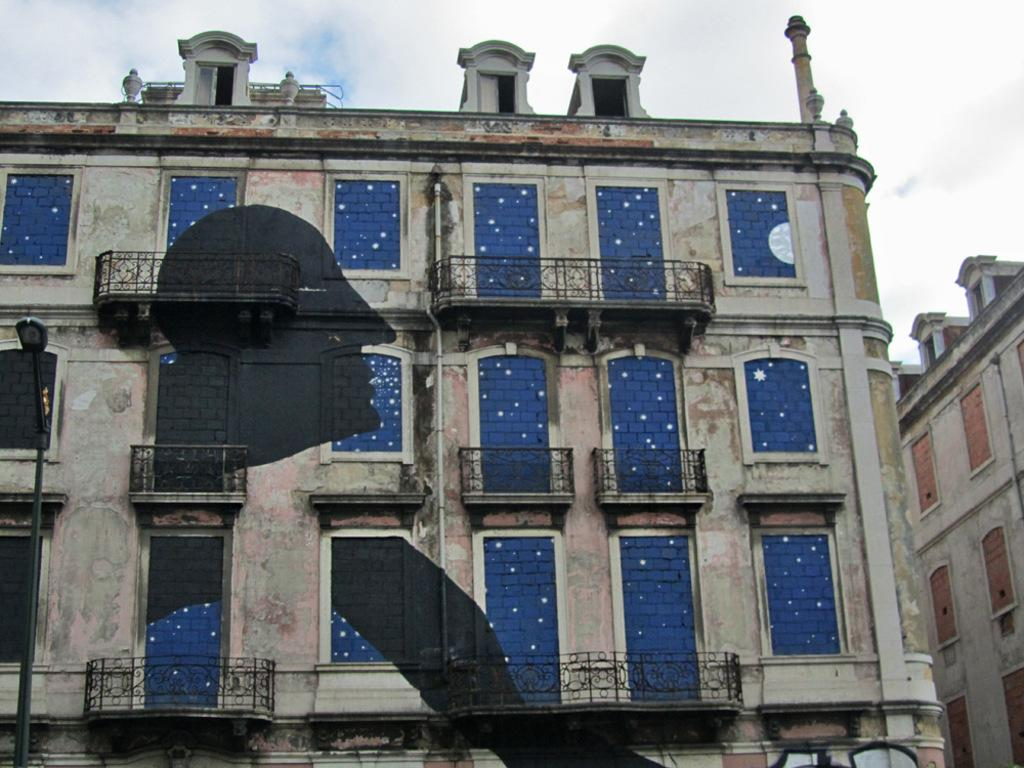What type of structures can be seen in the image? There are buildings in the image. What is the tall, vertical object in the image? There is a light pole in the image. What architectural features are present on the buildings? There are balconies in the image. What can be seen on the buildings that allow light and air to enter? There are windows in the image. What is visible in the background of the image? The sky is visible in the image. Based on the lighting and visibility of the sky, when do you think the image was taken? The image was likely taken during the day. What grade did the kitten receive on its latest report card in the image? There is no kitten present in the image, and therefore no report card or grade can be observed. What invention is being demonstrated by the light pole in the image? The light pole in the image is not demonstrating any invention; it is simply a tall, vertical object providing light. 